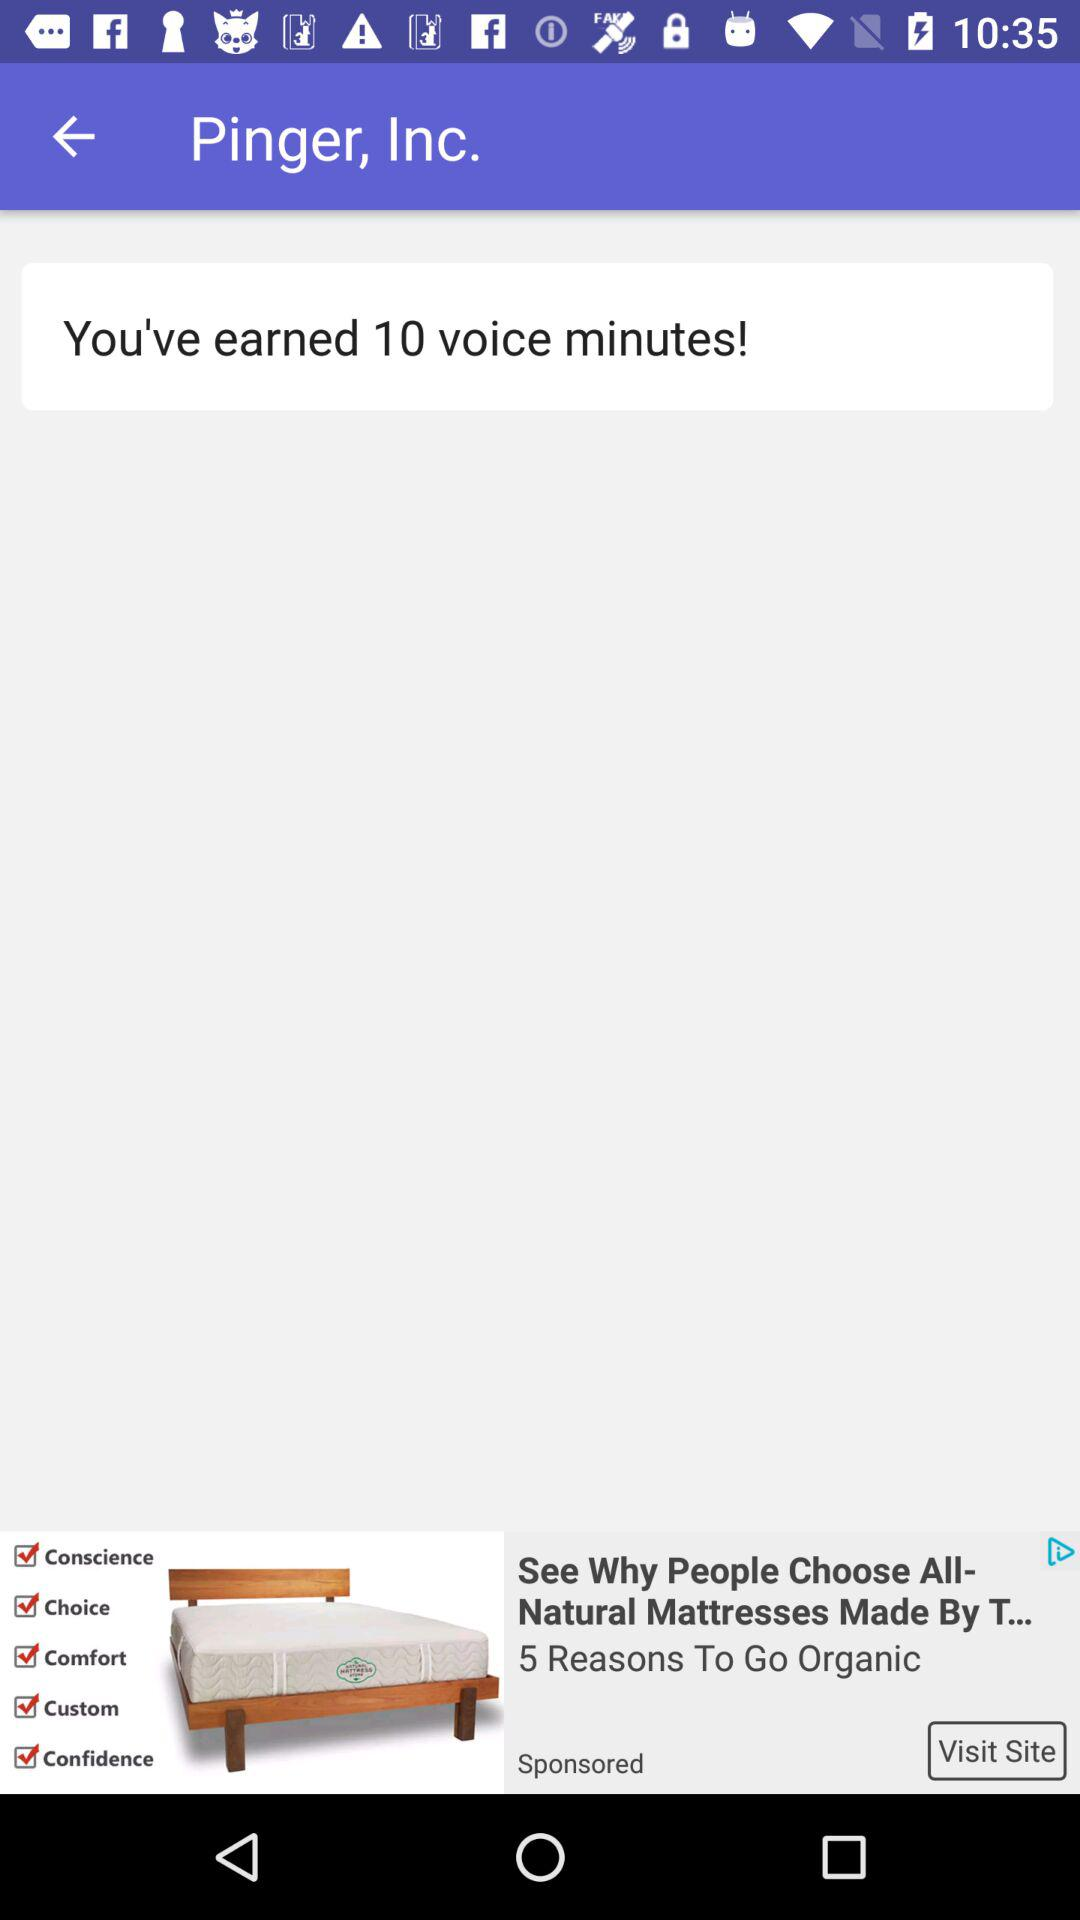How many voice minutes has the user used?
When the provided information is insufficient, respond with <no answer>. <no answer> 